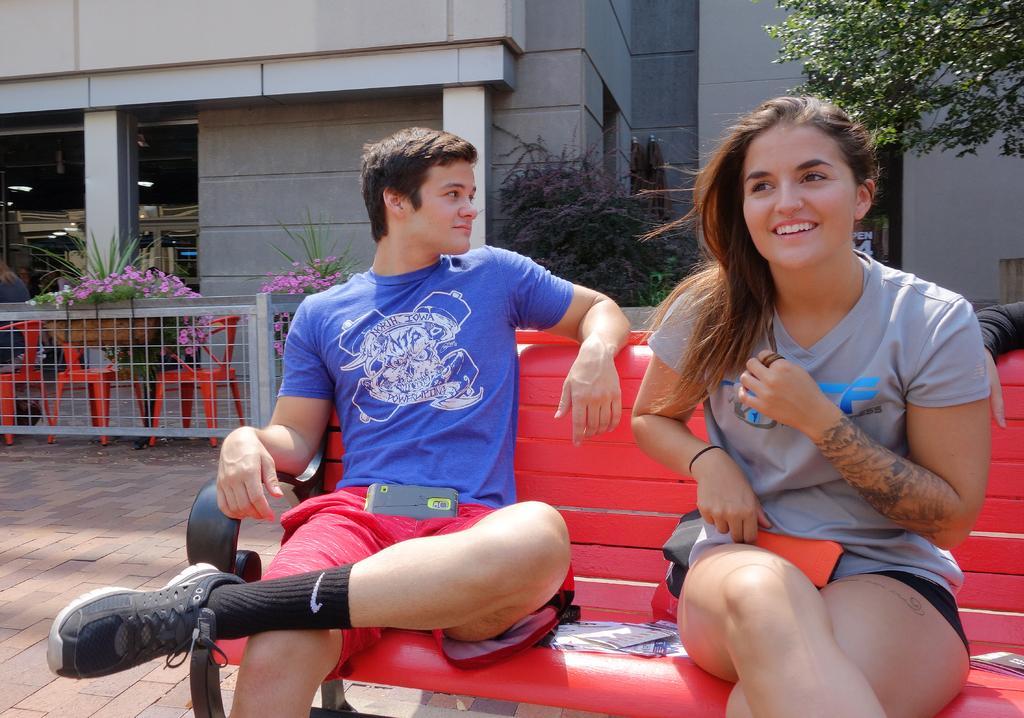In one or two sentences, can you explain what this image depicts? There is a girl and a boy sitting on a bench in the foreground area of the image, there are flower plants, chairs, boundary, building structure and a tree in the background. 